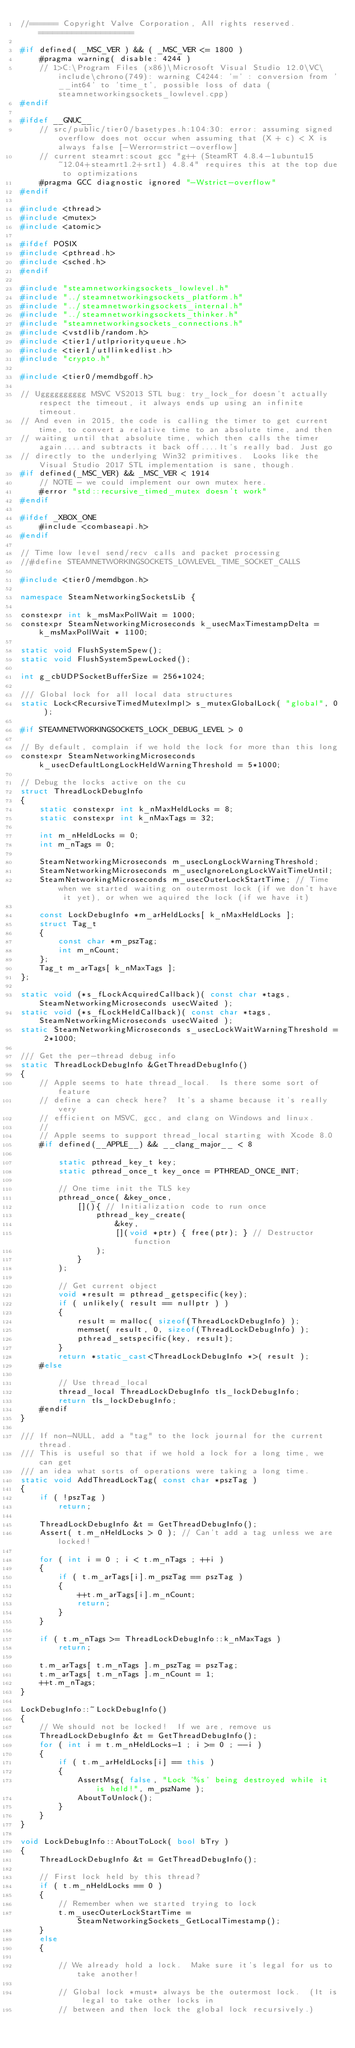Convert code to text. <code><loc_0><loc_0><loc_500><loc_500><_C++_>//====== Copyright Valve Corporation, All rights reserved. ====================

#if defined( _MSC_VER ) && ( _MSC_VER <= 1800 )
	#pragma warning( disable: 4244 )
	// 1>C:\Program Files (x86)\Microsoft Visual Studio 12.0\VC\include\chrono(749): warning C4244: '=' : conversion from '__int64' to 'time_t', possible loss of data (steamnetworkingsockets_lowlevel.cpp)
#endif

#ifdef __GNUC__
	// src/public/tier0/basetypes.h:104:30: error: assuming signed overflow does not occur when assuming that (X + c) < X is always false [-Werror=strict-overflow]
	// current steamrt:scout gcc "g++ (SteamRT 4.8.4-1ubuntu15~12.04+steamrt1.2+srt1) 4.8.4" requires this at the top due to optimizations
	#pragma GCC diagnostic ignored "-Wstrict-overflow"
#endif

#include <thread>
#include <mutex>
#include <atomic>

#ifdef POSIX
#include <pthread.h>
#include <sched.h>
#endif

#include "steamnetworkingsockets_lowlevel.h"
#include "../steamnetworkingsockets_platform.h"
#include "../steamnetworkingsockets_internal.h"
#include "../steamnetworkingsockets_thinker.h"
#include "steamnetworkingsockets_connections.h"
#include <vstdlib/random.h>
#include <tier1/utlpriorityqueue.h>
#include <tier1/utllinkedlist.h>
#include "crypto.h"

#include <tier0/memdbgoff.h>

// Ugggggggggg MSVC VS2013 STL bug: try_lock_for doesn't actually respect the timeout, it always ends up using an infinite timeout.
// And even in 2015, the code is calling the timer to get current time, to convert a relative time to an absolute time, and then
// waiting until that absolute time, which then calls the timer again....and subtracts it back off....It's really bad. Just go
// directly to the underlying Win32 primitives.  Looks like the Visual Studio 2017 STL implementation is sane, though.
#if defined(_MSC_VER) && _MSC_VER < 1914
	// NOTE - we could implement our own mutex here.
	#error "std::recursive_timed_mutex doesn't work"
#endif

#ifdef _XBOX_ONE
	#include <combaseapi.h>
#endif

// Time low level send/recv calls and packet processing
//#define STEAMNETWORKINGSOCKETS_LOWLEVEL_TIME_SOCKET_CALLS

#include <tier0/memdbgon.h>

namespace SteamNetworkingSocketsLib {

constexpr int k_msMaxPollWait = 1000;
constexpr SteamNetworkingMicroseconds k_usecMaxTimestampDelta = k_msMaxPollWait * 1100;

static void FlushSystemSpew();
static void FlushSystemSpewLocked();

int g_cbUDPSocketBufferSize = 256*1024;

/// Global lock for all local data structures
static Lock<RecursiveTimedMutexImpl> s_mutexGlobalLock( "global", 0 );

#if STEAMNETWORKINGSOCKETS_LOCK_DEBUG_LEVEL > 0

// By default, complain if we hold the lock for more than this long
constexpr SteamNetworkingMicroseconds k_usecDefaultLongLockHeldWarningThreshold = 5*1000;

// Debug the locks active on the cu
struct ThreadLockDebugInfo
{
	static constexpr int k_nMaxHeldLocks = 8;
	static constexpr int k_nMaxTags = 32;

	int m_nHeldLocks = 0;
	int m_nTags = 0;

	SteamNetworkingMicroseconds m_usecLongLockWarningThreshold;
	SteamNetworkingMicroseconds m_usecIgnoreLongLockWaitTimeUntil;
	SteamNetworkingMicroseconds m_usecOuterLockStartTime; // Time when we started waiting on outermost lock (if we don't have it yet), or when we aquired the lock (if we have it)

	const LockDebugInfo *m_arHeldLocks[ k_nMaxHeldLocks ];
	struct Tag_t
	{
		const char *m_pszTag;
		int m_nCount;
	};
	Tag_t m_arTags[ k_nMaxTags ];
};

static void (*s_fLockAcquiredCallback)( const char *tags, SteamNetworkingMicroseconds usecWaited );
static void (*s_fLockHeldCallback)( const char *tags, SteamNetworkingMicroseconds usecWaited );
static SteamNetworkingMicroseconds s_usecLockWaitWarningThreshold = 2*1000;

/// Get the per-thread debug info
static ThreadLockDebugInfo &GetThreadDebugInfo()
{
	// Apple seems to hate thread_local.  Is there some sort of feature
	// define a can check here?  It's a shame because it's really very
	// efficient on MSVC, gcc, and clang on Windows and linux.
    //
    // Apple seems to support thread_local starting with Xcode 8.0
	#if defined(__APPLE__) && __clang_major__ < 8

		static pthread_key_t key;
		static pthread_once_t key_once = PTHREAD_ONCE_INIT;

		// One time init the TLS key
		pthread_once( &key_once,
			[](){ // Initialization code to run once
				pthread_key_create(
					&key,
					[](void *ptr) { free(ptr); } // Destructor function
				);
			}
		);

		// Get current object
		void *result = pthread_getspecific(key);
		if ( unlikely( result == nullptr ) )
		{
			result = malloc( sizeof(ThreadLockDebugInfo) );
			memset( result, 0, sizeof(ThreadLockDebugInfo) );
			pthread_setspecific(key, result);
		}
		return *static_cast<ThreadLockDebugInfo *>( result );
	#else

		// Use thread_local
		thread_local ThreadLockDebugInfo tls_lockDebugInfo;
		return tls_lockDebugInfo;
	#endif
}

/// If non-NULL, add a "tag" to the lock journal for the current thread.
/// This is useful so that if we hold a lock for a long time, we can get
/// an idea what sorts of operations were taking a long time.
static void AddThreadLockTag( const char *pszTag )
{
	if ( !pszTag )
		return;

	ThreadLockDebugInfo &t = GetThreadDebugInfo();
	Assert( t.m_nHeldLocks > 0 ); // Can't add a tag unless we are locked!

	for ( int i = 0 ; i < t.m_nTags ; ++i )
	{
		if ( t.m_arTags[i].m_pszTag == pszTag )
		{
			++t.m_arTags[i].m_nCount;
			return;
		}
	}

	if ( t.m_nTags >= ThreadLockDebugInfo::k_nMaxTags )
		return;

	t.m_arTags[ t.m_nTags ].m_pszTag = pszTag;
	t.m_arTags[ t.m_nTags ].m_nCount = 1;
	++t.m_nTags;
}

LockDebugInfo::~LockDebugInfo()
{
	// We should not be locked!  If we are, remove us
	ThreadLockDebugInfo &t = GetThreadDebugInfo();
	for ( int i = t.m_nHeldLocks-1 ; i >= 0 ; --i )
	{
		if ( t.m_arHeldLocks[i] == this )
		{
			AssertMsg( false, "Lock '%s' being destroyed while it is held!", m_pszName );
			AboutToUnlock();
		}
	}
}

void LockDebugInfo::AboutToLock( bool bTry )
{
	ThreadLockDebugInfo &t = GetThreadDebugInfo();

	// First lock held by this thread?
	if ( t.m_nHeldLocks == 0 )
	{
		// Remember when we started trying to lock
		t.m_usecOuterLockStartTime = SteamNetworkingSockets_GetLocalTimestamp();
	}
	else
	{

		// We already hold a lock.  Make sure it's legal for us to take another!

		// Global lock *must* always be the outermost lock.  (It is legal to take other locks in
		// between and then lock the global lock recursively.)</code> 